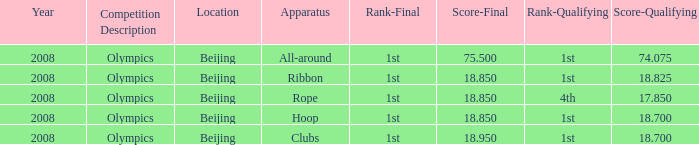What was her lowest ultimate score with a qualifying score of 7 75.5. 